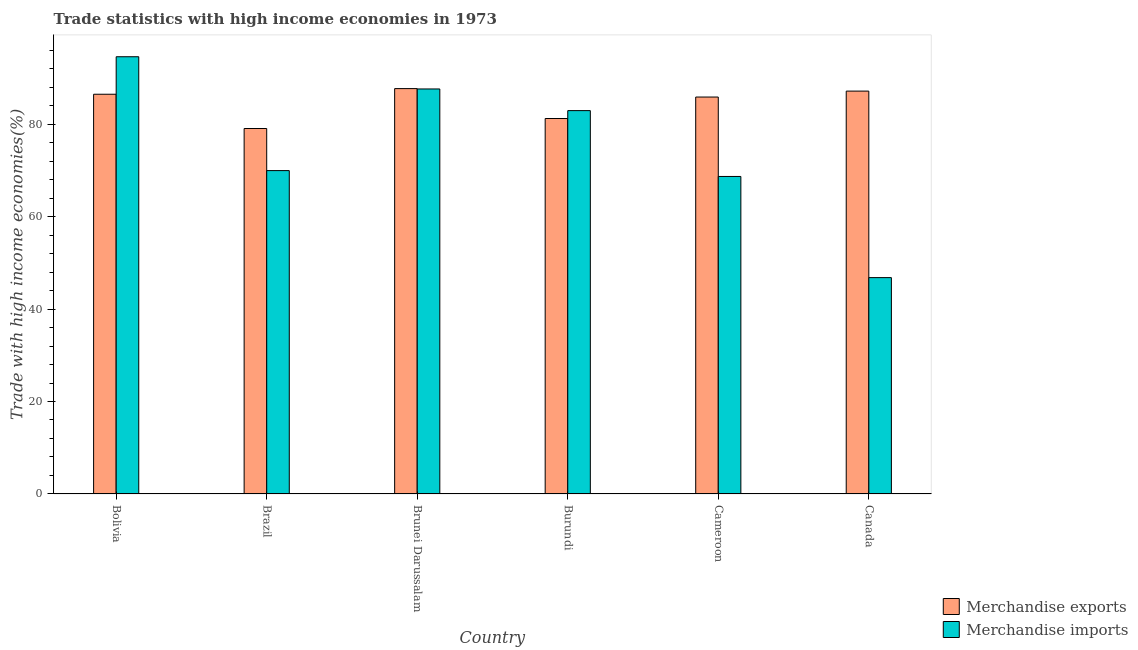Are the number of bars per tick equal to the number of legend labels?
Offer a very short reply. Yes. Are the number of bars on each tick of the X-axis equal?
Offer a terse response. Yes. How many bars are there on the 1st tick from the left?
Ensure brevity in your answer.  2. In how many cases, is the number of bars for a given country not equal to the number of legend labels?
Provide a succinct answer. 0. What is the merchandise imports in Cameroon?
Ensure brevity in your answer.  68.67. Across all countries, what is the maximum merchandise imports?
Ensure brevity in your answer.  94.57. Across all countries, what is the minimum merchandise exports?
Your response must be concise. 79.05. In which country was the merchandise imports maximum?
Ensure brevity in your answer.  Bolivia. What is the total merchandise exports in the graph?
Keep it short and to the point. 507.38. What is the difference between the merchandise exports in Brazil and that in Cameroon?
Give a very brief answer. -6.81. What is the difference between the merchandise exports in Burundi and the merchandise imports in Cameroon?
Your response must be concise. 12.53. What is the average merchandise imports per country?
Ensure brevity in your answer.  75.08. What is the difference between the merchandise exports and merchandise imports in Burundi?
Make the answer very short. -1.71. In how many countries, is the merchandise exports greater than 52 %?
Provide a short and direct response. 6. What is the ratio of the merchandise imports in Cameroon to that in Canada?
Offer a terse response. 1.47. Is the difference between the merchandise exports in Bolivia and Burundi greater than the difference between the merchandise imports in Bolivia and Burundi?
Provide a succinct answer. No. What is the difference between the highest and the second highest merchandise imports?
Provide a short and direct response. 6.97. What is the difference between the highest and the lowest merchandise exports?
Give a very brief answer. 8.63. In how many countries, is the merchandise imports greater than the average merchandise imports taken over all countries?
Your answer should be compact. 3. Is the sum of the merchandise imports in Brazil and Canada greater than the maximum merchandise exports across all countries?
Provide a short and direct response. Yes. What does the 2nd bar from the left in Brazil represents?
Make the answer very short. Merchandise imports. How many bars are there?
Offer a terse response. 12. Are all the bars in the graph horizontal?
Your answer should be very brief. No. How many countries are there in the graph?
Your answer should be very brief. 6. What is the difference between two consecutive major ticks on the Y-axis?
Provide a succinct answer. 20. Does the graph contain grids?
Ensure brevity in your answer.  No. Where does the legend appear in the graph?
Offer a very short reply. Bottom right. How many legend labels are there?
Give a very brief answer. 2. What is the title of the graph?
Your answer should be compact. Trade statistics with high income economies in 1973. What is the label or title of the X-axis?
Make the answer very short. Country. What is the label or title of the Y-axis?
Offer a very short reply. Trade with high income economies(%). What is the Trade with high income economies(%) in Merchandise exports in Bolivia?
Your answer should be compact. 86.45. What is the Trade with high income economies(%) in Merchandise imports in Bolivia?
Offer a terse response. 94.57. What is the Trade with high income economies(%) of Merchandise exports in Brazil?
Offer a terse response. 79.05. What is the Trade with high income economies(%) in Merchandise imports in Brazil?
Provide a succinct answer. 69.94. What is the Trade with high income economies(%) in Merchandise exports in Brunei Darussalam?
Offer a terse response. 87.68. What is the Trade with high income economies(%) in Merchandise imports in Brunei Darussalam?
Your response must be concise. 87.6. What is the Trade with high income economies(%) in Merchandise exports in Burundi?
Offer a terse response. 81.21. What is the Trade with high income economies(%) in Merchandise imports in Burundi?
Provide a succinct answer. 82.92. What is the Trade with high income economies(%) of Merchandise exports in Cameroon?
Your answer should be very brief. 85.85. What is the Trade with high income economies(%) of Merchandise imports in Cameroon?
Offer a terse response. 68.67. What is the Trade with high income economies(%) of Merchandise exports in Canada?
Your response must be concise. 87.14. What is the Trade with high income economies(%) of Merchandise imports in Canada?
Make the answer very short. 46.79. Across all countries, what is the maximum Trade with high income economies(%) in Merchandise exports?
Keep it short and to the point. 87.68. Across all countries, what is the maximum Trade with high income economies(%) of Merchandise imports?
Provide a succinct answer. 94.57. Across all countries, what is the minimum Trade with high income economies(%) in Merchandise exports?
Provide a short and direct response. 79.05. Across all countries, what is the minimum Trade with high income economies(%) in Merchandise imports?
Make the answer very short. 46.79. What is the total Trade with high income economies(%) of Merchandise exports in the graph?
Your answer should be compact. 507.38. What is the total Trade with high income economies(%) in Merchandise imports in the graph?
Offer a terse response. 450.49. What is the difference between the Trade with high income economies(%) of Merchandise exports in Bolivia and that in Brazil?
Provide a short and direct response. 7.41. What is the difference between the Trade with high income economies(%) in Merchandise imports in Bolivia and that in Brazil?
Provide a short and direct response. 24.63. What is the difference between the Trade with high income economies(%) of Merchandise exports in Bolivia and that in Brunei Darussalam?
Provide a short and direct response. -1.22. What is the difference between the Trade with high income economies(%) in Merchandise imports in Bolivia and that in Brunei Darussalam?
Your response must be concise. 6.97. What is the difference between the Trade with high income economies(%) in Merchandise exports in Bolivia and that in Burundi?
Your answer should be compact. 5.25. What is the difference between the Trade with high income economies(%) of Merchandise imports in Bolivia and that in Burundi?
Your response must be concise. 11.65. What is the difference between the Trade with high income economies(%) in Merchandise exports in Bolivia and that in Cameroon?
Provide a short and direct response. 0.6. What is the difference between the Trade with high income economies(%) of Merchandise imports in Bolivia and that in Cameroon?
Make the answer very short. 25.9. What is the difference between the Trade with high income economies(%) in Merchandise exports in Bolivia and that in Canada?
Give a very brief answer. -0.68. What is the difference between the Trade with high income economies(%) of Merchandise imports in Bolivia and that in Canada?
Your answer should be compact. 47.77. What is the difference between the Trade with high income economies(%) in Merchandise exports in Brazil and that in Brunei Darussalam?
Provide a succinct answer. -8.63. What is the difference between the Trade with high income economies(%) in Merchandise imports in Brazil and that in Brunei Darussalam?
Ensure brevity in your answer.  -17.66. What is the difference between the Trade with high income economies(%) in Merchandise exports in Brazil and that in Burundi?
Make the answer very short. -2.16. What is the difference between the Trade with high income economies(%) of Merchandise imports in Brazil and that in Burundi?
Provide a succinct answer. -12.98. What is the difference between the Trade with high income economies(%) in Merchandise exports in Brazil and that in Cameroon?
Give a very brief answer. -6.81. What is the difference between the Trade with high income economies(%) in Merchandise imports in Brazil and that in Cameroon?
Offer a terse response. 1.27. What is the difference between the Trade with high income economies(%) of Merchandise exports in Brazil and that in Canada?
Offer a very short reply. -8.09. What is the difference between the Trade with high income economies(%) in Merchandise imports in Brazil and that in Canada?
Offer a terse response. 23.15. What is the difference between the Trade with high income economies(%) of Merchandise exports in Brunei Darussalam and that in Burundi?
Ensure brevity in your answer.  6.47. What is the difference between the Trade with high income economies(%) in Merchandise imports in Brunei Darussalam and that in Burundi?
Give a very brief answer. 4.68. What is the difference between the Trade with high income economies(%) of Merchandise exports in Brunei Darussalam and that in Cameroon?
Your answer should be compact. 1.83. What is the difference between the Trade with high income economies(%) in Merchandise imports in Brunei Darussalam and that in Cameroon?
Offer a very short reply. 18.92. What is the difference between the Trade with high income economies(%) in Merchandise exports in Brunei Darussalam and that in Canada?
Offer a very short reply. 0.54. What is the difference between the Trade with high income economies(%) in Merchandise imports in Brunei Darussalam and that in Canada?
Your answer should be compact. 40.8. What is the difference between the Trade with high income economies(%) of Merchandise exports in Burundi and that in Cameroon?
Ensure brevity in your answer.  -4.64. What is the difference between the Trade with high income economies(%) in Merchandise imports in Burundi and that in Cameroon?
Give a very brief answer. 14.24. What is the difference between the Trade with high income economies(%) of Merchandise exports in Burundi and that in Canada?
Your answer should be compact. -5.93. What is the difference between the Trade with high income economies(%) of Merchandise imports in Burundi and that in Canada?
Ensure brevity in your answer.  36.12. What is the difference between the Trade with high income economies(%) in Merchandise exports in Cameroon and that in Canada?
Keep it short and to the point. -1.28. What is the difference between the Trade with high income economies(%) in Merchandise imports in Cameroon and that in Canada?
Provide a succinct answer. 21.88. What is the difference between the Trade with high income economies(%) in Merchandise exports in Bolivia and the Trade with high income economies(%) in Merchandise imports in Brazil?
Ensure brevity in your answer.  16.51. What is the difference between the Trade with high income economies(%) of Merchandise exports in Bolivia and the Trade with high income economies(%) of Merchandise imports in Brunei Darussalam?
Your response must be concise. -1.14. What is the difference between the Trade with high income economies(%) of Merchandise exports in Bolivia and the Trade with high income economies(%) of Merchandise imports in Burundi?
Ensure brevity in your answer.  3.54. What is the difference between the Trade with high income economies(%) in Merchandise exports in Bolivia and the Trade with high income economies(%) in Merchandise imports in Cameroon?
Make the answer very short. 17.78. What is the difference between the Trade with high income economies(%) in Merchandise exports in Bolivia and the Trade with high income economies(%) in Merchandise imports in Canada?
Give a very brief answer. 39.66. What is the difference between the Trade with high income economies(%) of Merchandise exports in Brazil and the Trade with high income economies(%) of Merchandise imports in Brunei Darussalam?
Your answer should be very brief. -8.55. What is the difference between the Trade with high income economies(%) in Merchandise exports in Brazil and the Trade with high income economies(%) in Merchandise imports in Burundi?
Offer a very short reply. -3.87. What is the difference between the Trade with high income economies(%) of Merchandise exports in Brazil and the Trade with high income economies(%) of Merchandise imports in Cameroon?
Make the answer very short. 10.37. What is the difference between the Trade with high income economies(%) of Merchandise exports in Brazil and the Trade with high income economies(%) of Merchandise imports in Canada?
Your answer should be very brief. 32.25. What is the difference between the Trade with high income economies(%) of Merchandise exports in Brunei Darussalam and the Trade with high income economies(%) of Merchandise imports in Burundi?
Offer a terse response. 4.76. What is the difference between the Trade with high income economies(%) of Merchandise exports in Brunei Darussalam and the Trade with high income economies(%) of Merchandise imports in Cameroon?
Offer a terse response. 19. What is the difference between the Trade with high income economies(%) of Merchandise exports in Brunei Darussalam and the Trade with high income economies(%) of Merchandise imports in Canada?
Give a very brief answer. 40.88. What is the difference between the Trade with high income economies(%) in Merchandise exports in Burundi and the Trade with high income economies(%) in Merchandise imports in Cameroon?
Give a very brief answer. 12.53. What is the difference between the Trade with high income economies(%) of Merchandise exports in Burundi and the Trade with high income economies(%) of Merchandise imports in Canada?
Provide a short and direct response. 34.41. What is the difference between the Trade with high income economies(%) of Merchandise exports in Cameroon and the Trade with high income economies(%) of Merchandise imports in Canada?
Your answer should be compact. 39.06. What is the average Trade with high income economies(%) of Merchandise exports per country?
Make the answer very short. 84.56. What is the average Trade with high income economies(%) in Merchandise imports per country?
Give a very brief answer. 75.08. What is the difference between the Trade with high income economies(%) in Merchandise exports and Trade with high income economies(%) in Merchandise imports in Bolivia?
Ensure brevity in your answer.  -8.11. What is the difference between the Trade with high income economies(%) of Merchandise exports and Trade with high income economies(%) of Merchandise imports in Brazil?
Your response must be concise. 9.11. What is the difference between the Trade with high income economies(%) of Merchandise exports and Trade with high income economies(%) of Merchandise imports in Brunei Darussalam?
Provide a short and direct response. 0.08. What is the difference between the Trade with high income economies(%) in Merchandise exports and Trade with high income economies(%) in Merchandise imports in Burundi?
Your answer should be compact. -1.71. What is the difference between the Trade with high income economies(%) of Merchandise exports and Trade with high income economies(%) of Merchandise imports in Cameroon?
Ensure brevity in your answer.  17.18. What is the difference between the Trade with high income economies(%) of Merchandise exports and Trade with high income economies(%) of Merchandise imports in Canada?
Keep it short and to the point. 40.34. What is the ratio of the Trade with high income economies(%) in Merchandise exports in Bolivia to that in Brazil?
Make the answer very short. 1.09. What is the ratio of the Trade with high income economies(%) in Merchandise imports in Bolivia to that in Brazil?
Provide a succinct answer. 1.35. What is the ratio of the Trade with high income economies(%) of Merchandise exports in Bolivia to that in Brunei Darussalam?
Keep it short and to the point. 0.99. What is the ratio of the Trade with high income economies(%) of Merchandise imports in Bolivia to that in Brunei Darussalam?
Offer a terse response. 1.08. What is the ratio of the Trade with high income economies(%) of Merchandise exports in Bolivia to that in Burundi?
Your answer should be compact. 1.06. What is the ratio of the Trade with high income economies(%) in Merchandise imports in Bolivia to that in Burundi?
Make the answer very short. 1.14. What is the ratio of the Trade with high income economies(%) of Merchandise imports in Bolivia to that in Cameroon?
Ensure brevity in your answer.  1.38. What is the ratio of the Trade with high income economies(%) in Merchandise exports in Bolivia to that in Canada?
Your answer should be very brief. 0.99. What is the ratio of the Trade with high income economies(%) in Merchandise imports in Bolivia to that in Canada?
Give a very brief answer. 2.02. What is the ratio of the Trade with high income economies(%) of Merchandise exports in Brazil to that in Brunei Darussalam?
Ensure brevity in your answer.  0.9. What is the ratio of the Trade with high income economies(%) in Merchandise imports in Brazil to that in Brunei Darussalam?
Give a very brief answer. 0.8. What is the ratio of the Trade with high income economies(%) in Merchandise exports in Brazil to that in Burundi?
Offer a very short reply. 0.97. What is the ratio of the Trade with high income economies(%) of Merchandise imports in Brazil to that in Burundi?
Provide a succinct answer. 0.84. What is the ratio of the Trade with high income economies(%) of Merchandise exports in Brazil to that in Cameroon?
Your response must be concise. 0.92. What is the ratio of the Trade with high income economies(%) of Merchandise imports in Brazil to that in Cameroon?
Your answer should be very brief. 1.02. What is the ratio of the Trade with high income economies(%) in Merchandise exports in Brazil to that in Canada?
Give a very brief answer. 0.91. What is the ratio of the Trade with high income economies(%) of Merchandise imports in Brazil to that in Canada?
Provide a succinct answer. 1.49. What is the ratio of the Trade with high income economies(%) of Merchandise exports in Brunei Darussalam to that in Burundi?
Keep it short and to the point. 1.08. What is the ratio of the Trade with high income economies(%) of Merchandise imports in Brunei Darussalam to that in Burundi?
Give a very brief answer. 1.06. What is the ratio of the Trade with high income economies(%) of Merchandise exports in Brunei Darussalam to that in Cameroon?
Your answer should be compact. 1.02. What is the ratio of the Trade with high income economies(%) of Merchandise imports in Brunei Darussalam to that in Cameroon?
Your response must be concise. 1.28. What is the ratio of the Trade with high income economies(%) in Merchandise imports in Brunei Darussalam to that in Canada?
Provide a succinct answer. 1.87. What is the ratio of the Trade with high income economies(%) of Merchandise exports in Burundi to that in Cameroon?
Your answer should be very brief. 0.95. What is the ratio of the Trade with high income economies(%) in Merchandise imports in Burundi to that in Cameroon?
Give a very brief answer. 1.21. What is the ratio of the Trade with high income economies(%) of Merchandise exports in Burundi to that in Canada?
Your answer should be very brief. 0.93. What is the ratio of the Trade with high income economies(%) of Merchandise imports in Burundi to that in Canada?
Your response must be concise. 1.77. What is the ratio of the Trade with high income economies(%) in Merchandise imports in Cameroon to that in Canada?
Offer a terse response. 1.47. What is the difference between the highest and the second highest Trade with high income economies(%) in Merchandise exports?
Provide a short and direct response. 0.54. What is the difference between the highest and the second highest Trade with high income economies(%) in Merchandise imports?
Your answer should be compact. 6.97. What is the difference between the highest and the lowest Trade with high income economies(%) of Merchandise exports?
Provide a short and direct response. 8.63. What is the difference between the highest and the lowest Trade with high income economies(%) of Merchandise imports?
Provide a short and direct response. 47.77. 